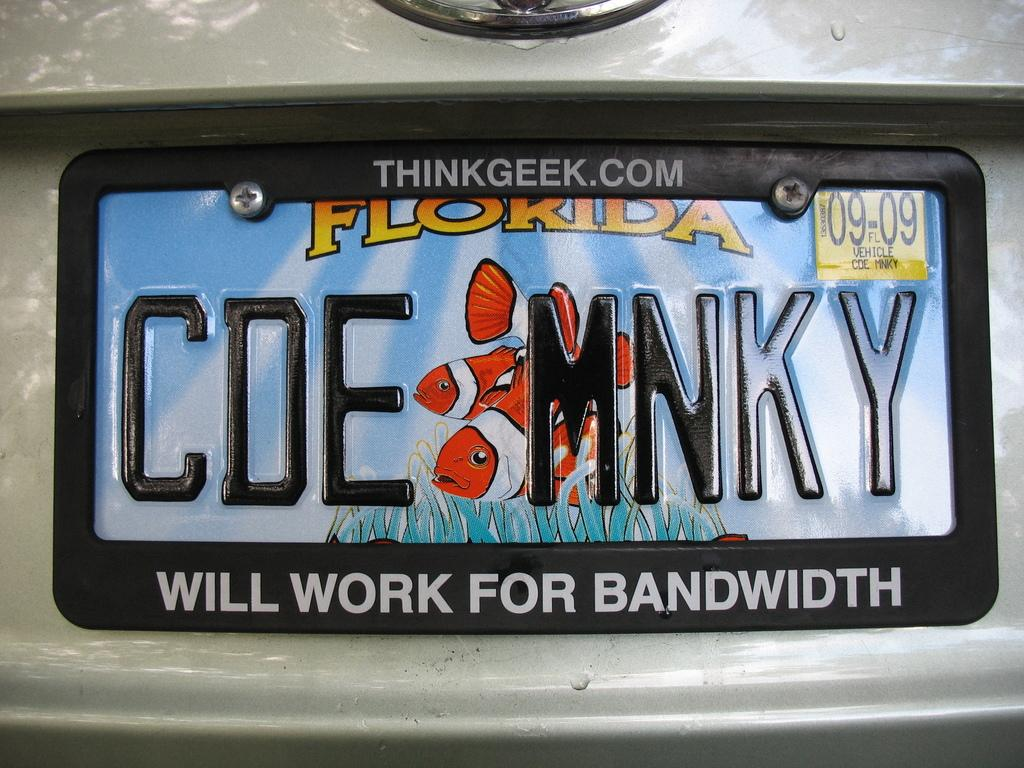<image>
Give a short and clear explanation of the subsequent image. License plate CDEMNKY has a frame that says will work for bandwidth. 